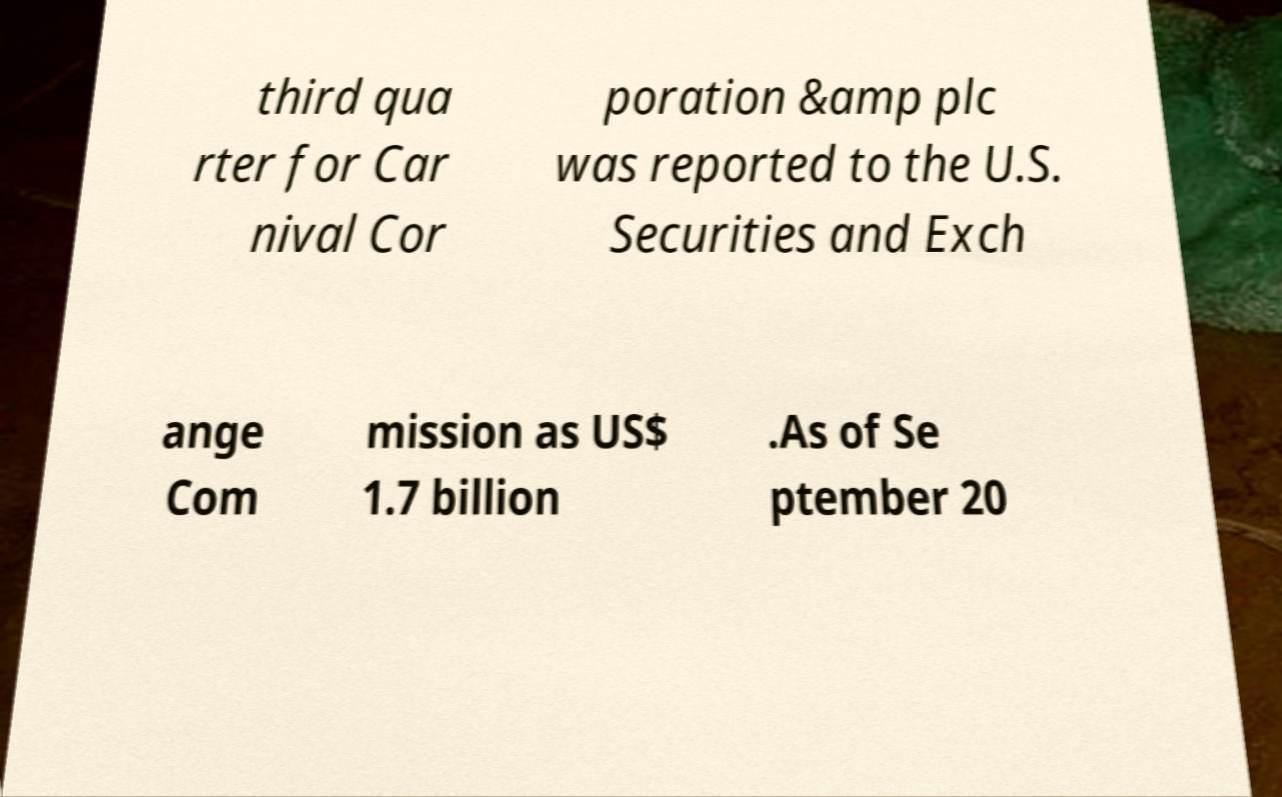There's text embedded in this image that I need extracted. Can you transcribe it verbatim? third qua rter for Car nival Cor poration &amp plc was reported to the U.S. Securities and Exch ange Com mission as US$ 1.7 billion .As of Se ptember 20 